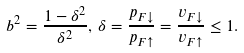<formula> <loc_0><loc_0><loc_500><loc_500>b ^ { 2 } = \frac { 1 - \delta ^ { 2 } } { \delta ^ { 2 } } , \, \delta = \frac { p _ { F \downarrow } } { p _ { F \uparrow } } = \frac { v _ { F \downarrow } } { v _ { F \uparrow } } \leq 1 .</formula> 